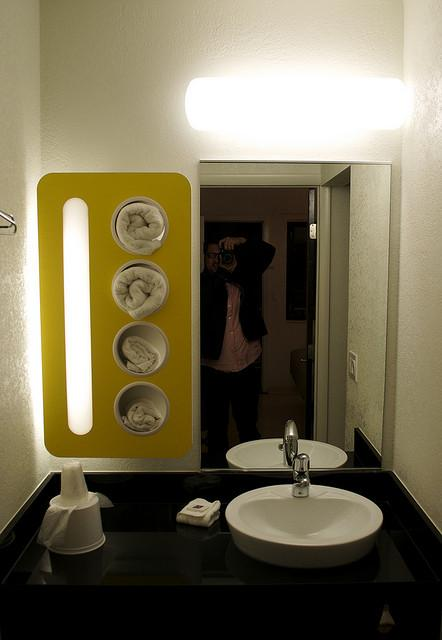What is near the sink? Please explain your reasoning. towel. There are towels hanging near the sink. 